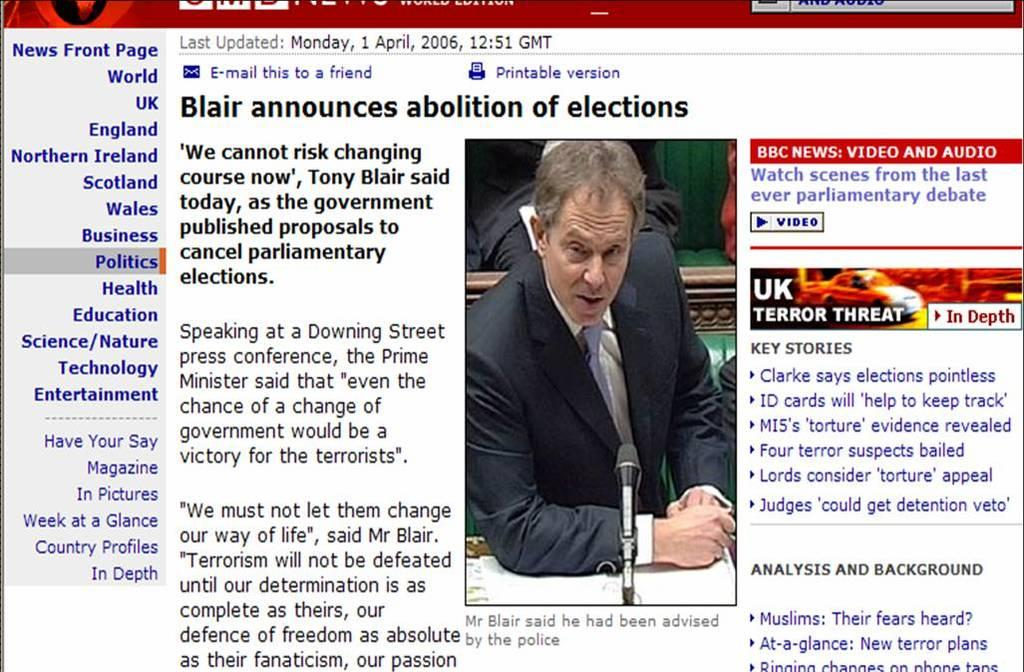What type of content is present on the web page? The web page contains an article. What is the article about? The article is about Blair announcing the abolition of elections. How does the society help the nation in the article? The article does not mention any information about society helping the nation; it is focused on Blair's announcement about the abolition of elections. 